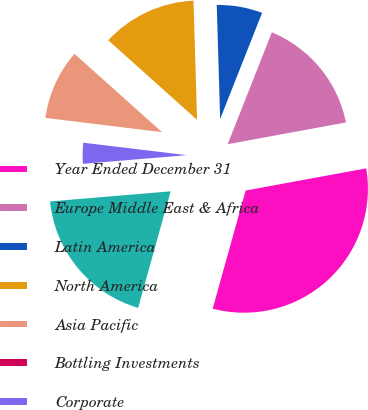Convert chart. <chart><loc_0><loc_0><loc_500><loc_500><pie_chart><fcel>Year Ended December 31<fcel>Europe Middle East & Africa<fcel>Latin America<fcel>North America<fcel>Asia Pacific<fcel>Bottling Investments<fcel>Corporate<fcel>Total<nl><fcel>32.22%<fcel>16.12%<fcel>6.46%<fcel>12.9%<fcel>9.68%<fcel>0.03%<fcel>3.24%<fcel>19.34%<nl></chart> 